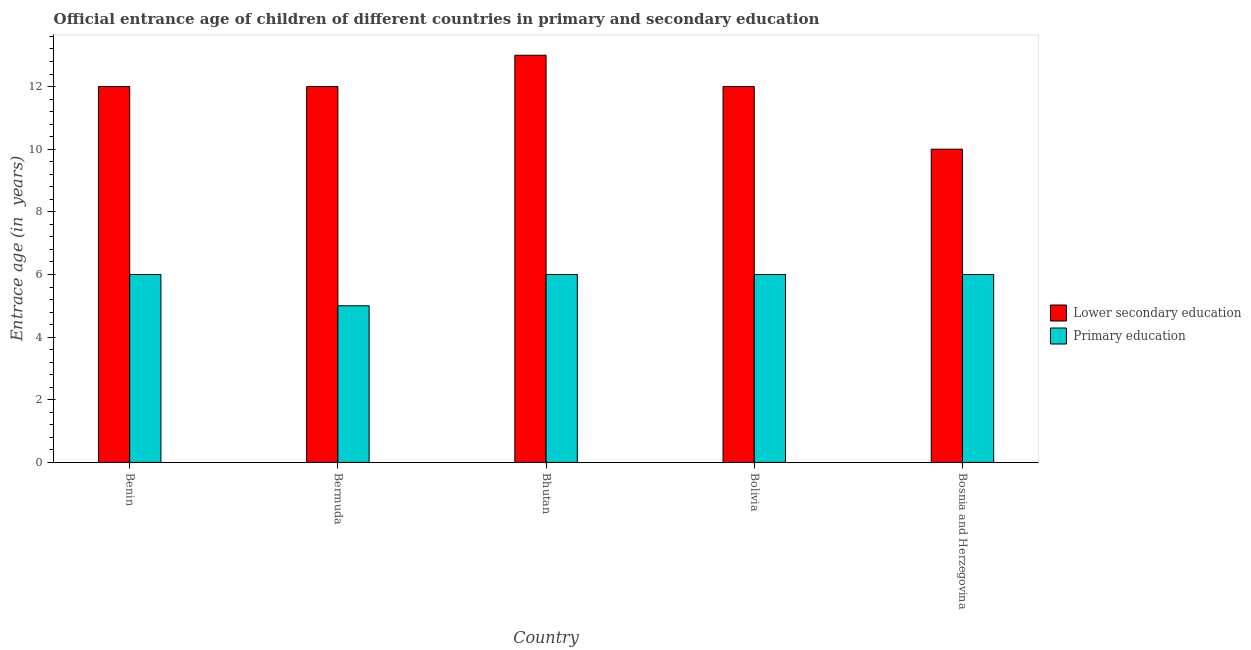How many groups of bars are there?
Ensure brevity in your answer.  5. How many bars are there on the 2nd tick from the left?
Your response must be concise. 2. How many bars are there on the 1st tick from the right?
Your answer should be compact. 2. What is the label of the 5th group of bars from the left?
Your answer should be very brief. Bosnia and Herzegovina. In how many cases, is the number of bars for a given country not equal to the number of legend labels?
Your answer should be compact. 0. What is the entrance age of children in lower secondary education in Bosnia and Herzegovina?
Make the answer very short. 10. Across all countries, what is the minimum entrance age of children in lower secondary education?
Ensure brevity in your answer.  10. In which country was the entrance age of chiildren in primary education maximum?
Give a very brief answer. Benin. In which country was the entrance age of children in lower secondary education minimum?
Offer a terse response. Bosnia and Herzegovina. What is the total entrance age of children in lower secondary education in the graph?
Provide a short and direct response. 59. What is the difference between the entrance age of chiildren in primary education in Bermuda and that in Bolivia?
Offer a terse response. -1. What is the average entrance age of chiildren in primary education per country?
Your answer should be very brief. 5.8. What is the difference between the entrance age of chiildren in primary education and entrance age of children in lower secondary education in Bermuda?
Offer a terse response. -7. In how many countries, is the entrance age of children in lower secondary education greater than 6 years?
Your answer should be compact. 5. What is the difference between the highest and the lowest entrance age of children in lower secondary education?
Your answer should be compact. 3. What does the 1st bar from the left in Bolivia represents?
Provide a short and direct response. Lower secondary education. Are all the bars in the graph horizontal?
Your response must be concise. No. What is the difference between two consecutive major ticks on the Y-axis?
Ensure brevity in your answer.  2. Where does the legend appear in the graph?
Give a very brief answer. Center right. How many legend labels are there?
Provide a succinct answer. 2. How are the legend labels stacked?
Ensure brevity in your answer.  Vertical. What is the title of the graph?
Make the answer very short. Official entrance age of children of different countries in primary and secondary education. What is the label or title of the Y-axis?
Provide a short and direct response. Entrace age (in  years). What is the Entrace age (in  years) in Lower secondary education in Benin?
Offer a terse response. 12. What is the Entrace age (in  years) of Primary education in Benin?
Your answer should be compact. 6. What is the Entrace age (in  years) in Primary education in Bhutan?
Keep it short and to the point. 6. What is the Entrace age (in  years) of Primary education in Bolivia?
Provide a succinct answer. 6. What is the Entrace age (in  years) of Primary education in Bosnia and Herzegovina?
Make the answer very short. 6. Across all countries, what is the maximum Entrace age (in  years) in Lower secondary education?
Your answer should be very brief. 13. Across all countries, what is the maximum Entrace age (in  years) in Primary education?
Make the answer very short. 6. Across all countries, what is the minimum Entrace age (in  years) of Lower secondary education?
Make the answer very short. 10. What is the difference between the Entrace age (in  years) of Lower secondary education in Benin and that in Bermuda?
Give a very brief answer. 0. What is the difference between the Entrace age (in  years) of Primary education in Benin and that in Bermuda?
Make the answer very short. 1. What is the difference between the Entrace age (in  years) in Lower secondary education in Benin and that in Bhutan?
Offer a very short reply. -1. What is the difference between the Entrace age (in  years) of Primary education in Benin and that in Bolivia?
Provide a succinct answer. 0. What is the difference between the Entrace age (in  years) of Lower secondary education in Benin and that in Bosnia and Herzegovina?
Your response must be concise. 2. What is the difference between the Entrace age (in  years) in Primary education in Benin and that in Bosnia and Herzegovina?
Give a very brief answer. 0. What is the difference between the Entrace age (in  years) of Primary education in Bermuda and that in Bhutan?
Your answer should be very brief. -1. What is the difference between the Entrace age (in  years) of Lower secondary education in Bermuda and that in Bolivia?
Make the answer very short. 0. What is the difference between the Entrace age (in  years) of Lower secondary education in Bermuda and that in Bosnia and Herzegovina?
Your answer should be very brief. 2. What is the difference between the Entrace age (in  years) in Primary education in Bermuda and that in Bosnia and Herzegovina?
Provide a short and direct response. -1. What is the difference between the Entrace age (in  years) in Primary education in Bhutan and that in Bosnia and Herzegovina?
Your response must be concise. 0. What is the difference between the Entrace age (in  years) in Lower secondary education in Benin and the Entrace age (in  years) in Primary education in Bermuda?
Provide a succinct answer. 7. What is the difference between the Entrace age (in  years) of Lower secondary education in Benin and the Entrace age (in  years) of Primary education in Bhutan?
Give a very brief answer. 6. What is the difference between the Entrace age (in  years) in Lower secondary education in Benin and the Entrace age (in  years) in Primary education in Bolivia?
Your response must be concise. 6. What is the difference between the Entrace age (in  years) of Lower secondary education in Bermuda and the Entrace age (in  years) of Primary education in Bhutan?
Ensure brevity in your answer.  6. What is the difference between the Entrace age (in  years) in Lower secondary education in Bermuda and the Entrace age (in  years) in Primary education in Bolivia?
Your answer should be very brief. 6. What is the difference between the Entrace age (in  years) of Lower secondary education in Bhutan and the Entrace age (in  years) of Primary education in Bosnia and Herzegovina?
Your response must be concise. 7. What is the difference between the Entrace age (in  years) of Lower secondary education in Bolivia and the Entrace age (in  years) of Primary education in Bosnia and Herzegovina?
Keep it short and to the point. 6. What is the average Entrace age (in  years) of Lower secondary education per country?
Your answer should be compact. 11.8. What is the average Entrace age (in  years) in Primary education per country?
Make the answer very short. 5.8. What is the difference between the Entrace age (in  years) of Lower secondary education and Entrace age (in  years) of Primary education in Bolivia?
Provide a short and direct response. 6. What is the difference between the Entrace age (in  years) of Lower secondary education and Entrace age (in  years) of Primary education in Bosnia and Herzegovina?
Ensure brevity in your answer.  4. What is the ratio of the Entrace age (in  years) of Lower secondary education in Benin to that in Bermuda?
Provide a succinct answer. 1. What is the ratio of the Entrace age (in  years) of Primary education in Benin to that in Bermuda?
Your answer should be compact. 1.2. What is the ratio of the Entrace age (in  years) of Primary education in Benin to that in Bhutan?
Keep it short and to the point. 1. What is the ratio of the Entrace age (in  years) in Lower secondary education in Benin to that in Bolivia?
Your answer should be very brief. 1. What is the ratio of the Entrace age (in  years) in Primary education in Benin to that in Bolivia?
Keep it short and to the point. 1. What is the ratio of the Entrace age (in  years) of Lower secondary education in Benin to that in Bosnia and Herzegovina?
Offer a very short reply. 1.2. What is the ratio of the Entrace age (in  years) in Lower secondary education in Bermuda to that in Bosnia and Herzegovina?
Give a very brief answer. 1.2. What is the ratio of the Entrace age (in  years) in Primary education in Bermuda to that in Bosnia and Herzegovina?
Your response must be concise. 0.83. What is the ratio of the Entrace age (in  years) in Lower secondary education in Bhutan to that in Bolivia?
Offer a very short reply. 1.08. What is the ratio of the Entrace age (in  years) of Lower secondary education in Bhutan to that in Bosnia and Herzegovina?
Your answer should be very brief. 1.3. What is the ratio of the Entrace age (in  years) of Lower secondary education in Bolivia to that in Bosnia and Herzegovina?
Provide a short and direct response. 1.2. What is the ratio of the Entrace age (in  years) of Primary education in Bolivia to that in Bosnia and Herzegovina?
Your response must be concise. 1. What is the difference between the highest and the second highest Entrace age (in  years) in Lower secondary education?
Your answer should be very brief. 1. 